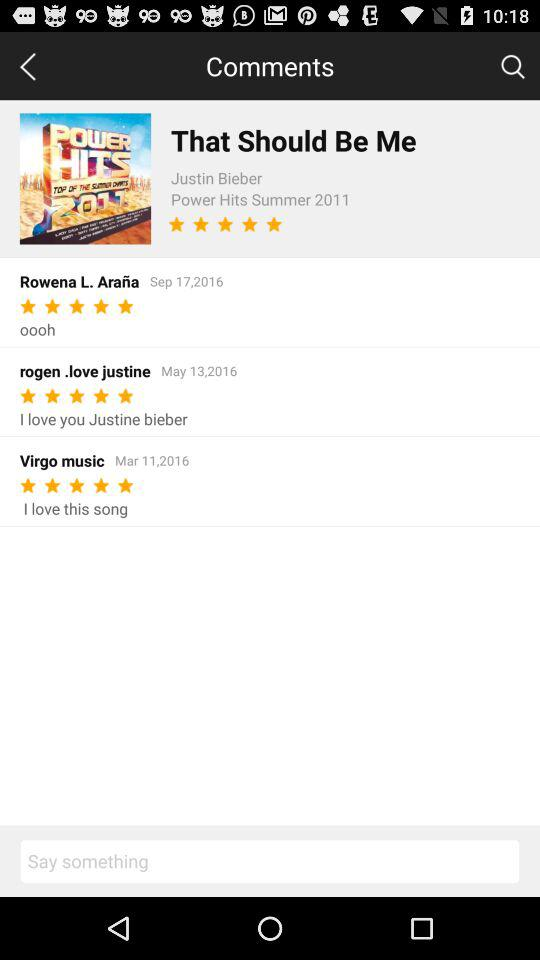What is the rating of the song? The rating of the song is 5 stars. 